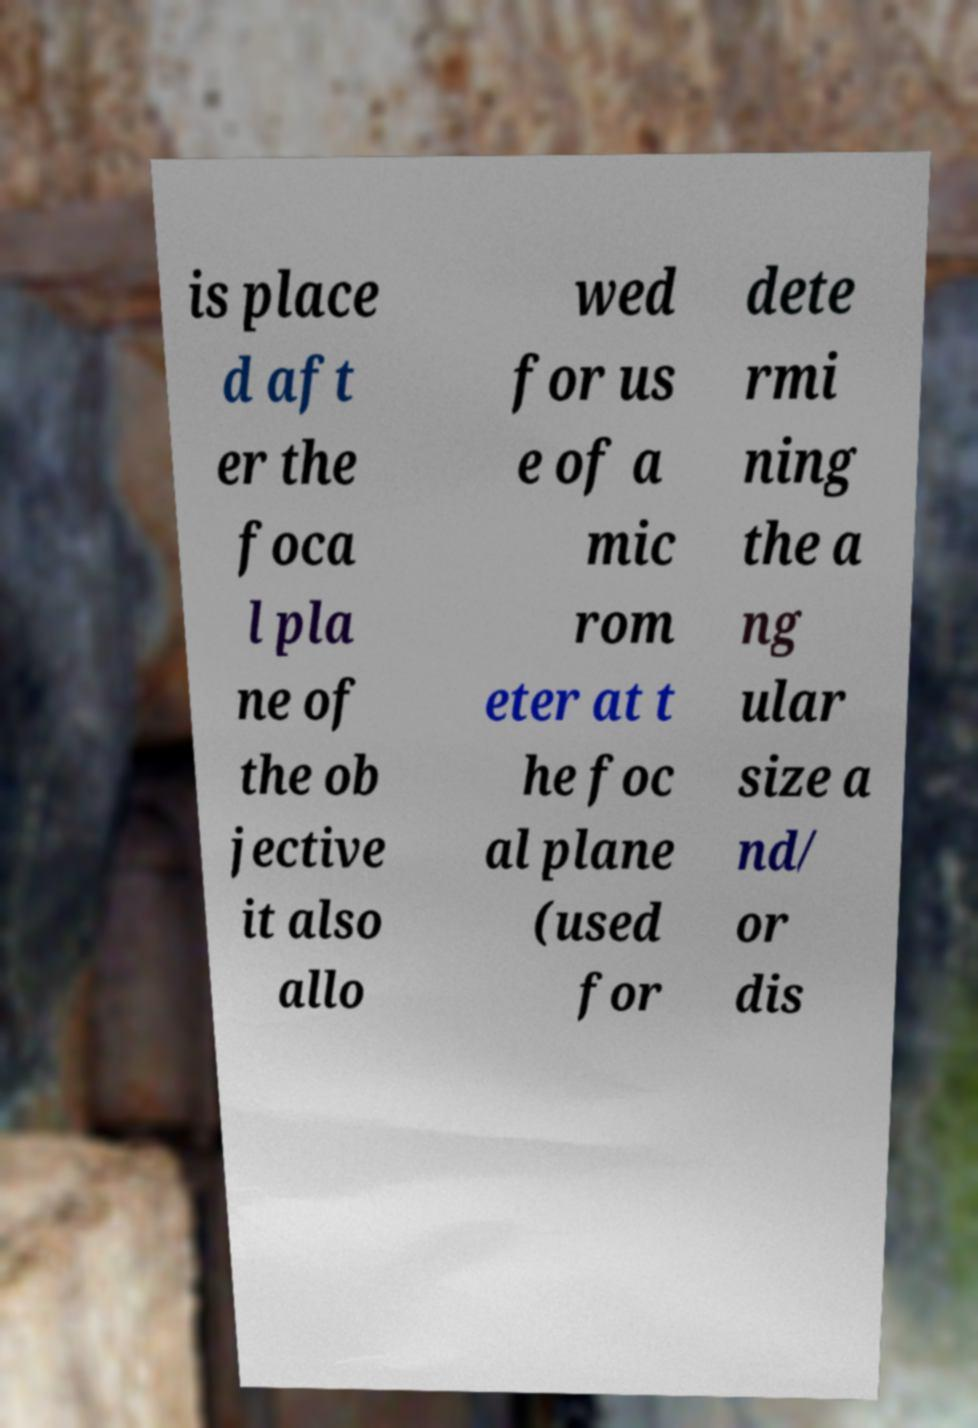Can you read and provide the text displayed in the image?This photo seems to have some interesting text. Can you extract and type it out for me? is place d aft er the foca l pla ne of the ob jective it also allo wed for us e of a mic rom eter at t he foc al plane (used for dete rmi ning the a ng ular size a nd/ or dis 